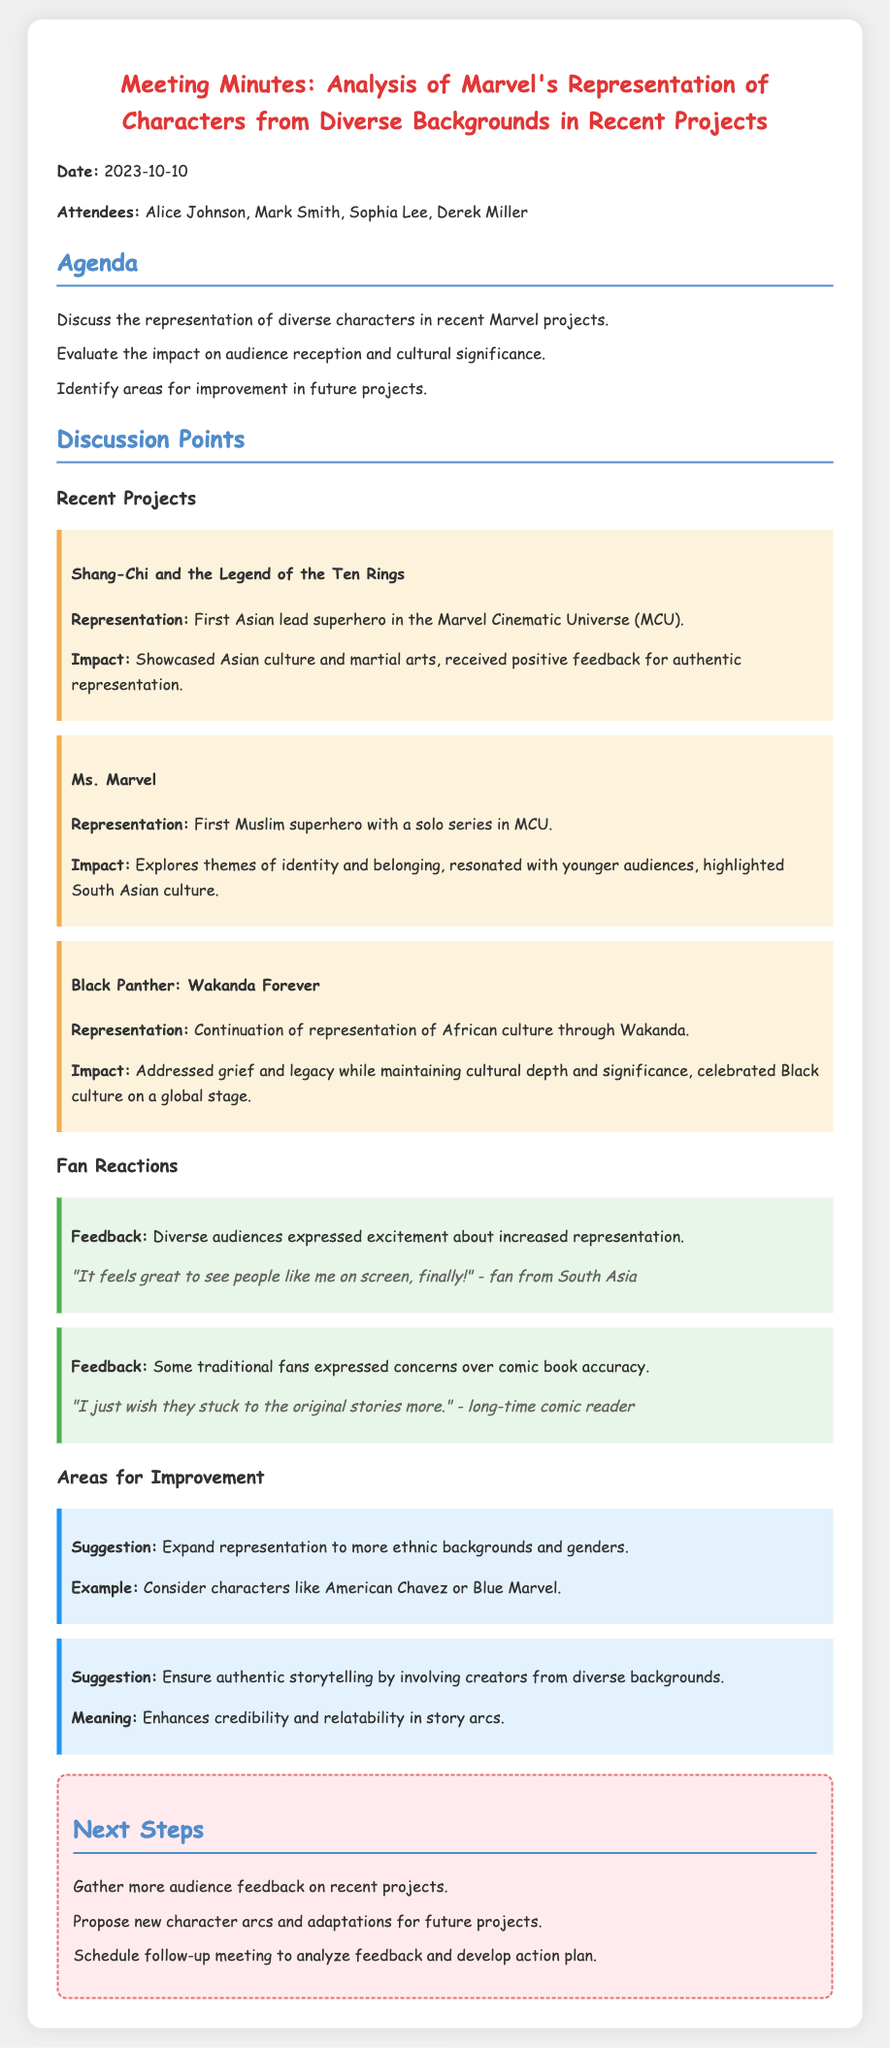What is the date of the meeting? The date of the meeting is stated in the document under the date heading, which is 2023-10-10.
Answer: 2023-10-10 Who was the first Asian lead superhero in the MCU? The document highlights the character from the project "Shang-Chi and the Legend of the Ten Rings" as the first Asian lead superhero.
Answer: Shang-Chi Which project is noted for having the first Muslim superhero with a solo series? The project that is acknowledged for this representation is "Ms. Marvel."
Answer: Ms. Marvel What was one of the fan reactions regarding the representation of diverse characters? One fan reaction noted that diverse audiences expressed excitement about increased representation.
Answer: Excitement What suggestion was made regarding future representation in Marvel projects? The suggestion included expanding representation to more ethnic backgrounds and genders.
Answer: Expand representation How did "Black Panther: Wakanda Forever" address cultural significance? The document states that it celebrated Black culture on a global stage while addressing grief and legacy.
Answer: Celebrated Black culture What is one reason for ensuring authentic storytelling in future projects? The document suggests that involving creators from diverse backgrounds enhances credibility and relatability in story arcs.
Answer: Enhances credibility What was mentioned as a next step in the meeting? Gathering more audience feedback on recent projects was listed as a next step.
Answer: Gather more audience feedback 